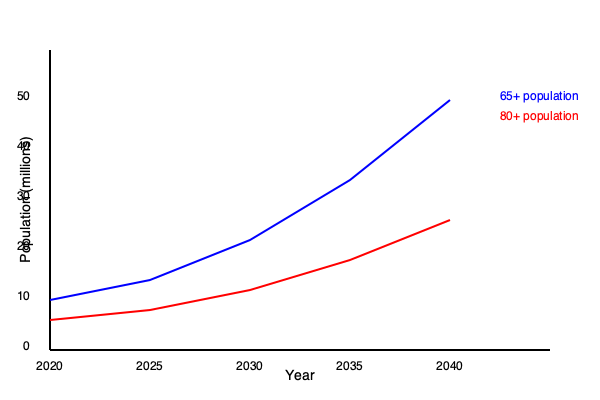Based on the demographic chart showing projected growth trends for the 65+ and 80+ populations from 2020 to 2040, what is the estimated ratio of the 80+ population to the 65+ population in 2040? To determine the ratio of the 80+ population to the 65+ population in 2040, we need to follow these steps:

1. Identify the values for both populations in 2040:
   - 65+ population (blue line) in 2040: approximately 47 million
   - 80+ population (red line) in 2040: approximately 26 million

2. Calculate the ratio by dividing the 80+ population by the 65+ population:
   $\text{Ratio} = \frac{80+ \text{ population}}{65+ \text{ population}} = \frac{26}{47}$

3. Simplify the fraction:
   $\frac{26}{47} \approx 0.5532$

4. Convert to a simplified ratio:
   $0.5532 \approx \frac{5.5}{10} \approx \frac{11}{20}$

Therefore, the estimated ratio of the 80+ population to the 65+ population in 2040 is approximately 11:20.
Answer: 11:20 